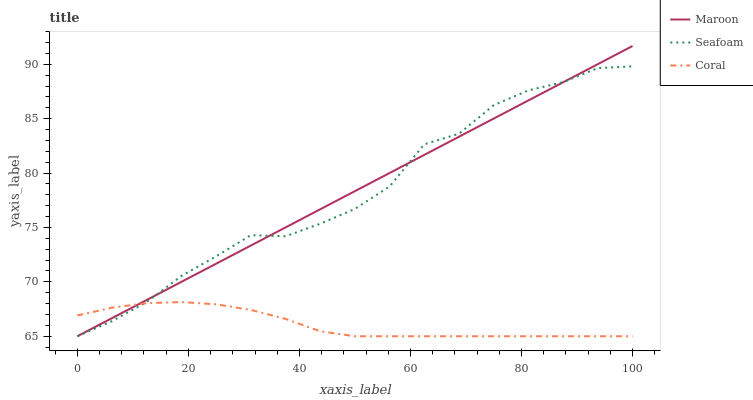Does Coral have the minimum area under the curve?
Answer yes or no. Yes. Does Maroon have the maximum area under the curve?
Answer yes or no. Yes. Does Seafoam have the minimum area under the curve?
Answer yes or no. No. Does Seafoam have the maximum area under the curve?
Answer yes or no. No. Is Maroon the smoothest?
Answer yes or no. Yes. Is Seafoam the roughest?
Answer yes or no. Yes. Is Seafoam the smoothest?
Answer yes or no. No. Is Maroon the roughest?
Answer yes or no. No. Does Coral have the lowest value?
Answer yes or no. Yes. Does Maroon have the highest value?
Answer yes or no. Yes. Does Seafoam have the highest value?
Answer yes or no. No. Does Maroon intersect Seafoam?
Answer yes or no. Yes. Is Maroon less than Seafoam?
Answer yes or no. No. Is Maroon greater than Seafoam?
Answer yes or no. No. 